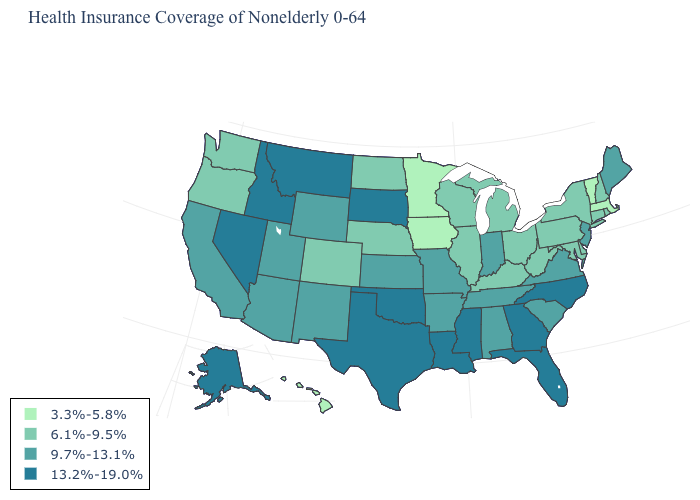How many symbols are there in the legend?
Be succinct. 4. What is the value of Tennessee?
Give a very brief answer. 9.7%-13.1%. What is the value of New Jersey?
Concise answer only. 9.7%-13.1%. Which states have the lowest value in the USA?
Be succinct. Hawaii, Iowa, Massachusetts, Minnesota, Vermont. Does Hawaii have the lowest value in the USA?
Keep it brief. Yes. What is the value of Pennsylvania?
Keep it brief. 6.1%-9.5%. Does Kentucky have the lowest value in the USA?
Keep it brief. No. Among the states that border New Mexico , which have the highest value?
Keep it brief. Oklahoma, Texas. Name the states that have a value in the range 13.2%-19.0%?
Answer briefly. Alaska, Florida, Georgia, Idaho, Louisiana, Mississippi, Montana, Nevada, North Carolina, Oklahoma, South Dakota, Texas. Does the map have missing data?
Be succinct. No. What is the value of New Mexico?
Concise answer only. 9.7%-13.1%. Does West Virginia have the lowest value in the USA?
Give a very brief answer. No. What is the value of Pennsylvania?
Answer briefly. 6.1%-9.5%. What is the highest value in states that border South Dakota?
Answer briefly. 13.2%-19.0%. Name the states that have a value in the range 3.3%-5.8%?
Answer briefly. Hawaii, Iowa, Massachusetts, Minnesota, Vermont. 